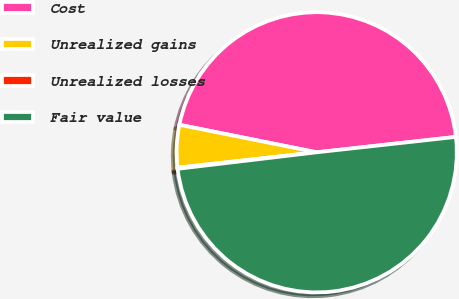Convert chart to OTSL. <chart><loc_0><loc_0><loc_500><loc_500><pie_chart><fcel>Cost<fcel>Unrealized gains<fcel>Unrealized losses<fcel>Fair value<nl><fcel>45.1%<fcel>4.9%<fcel>0.13%<fcel>49.87%<nl></chart> 